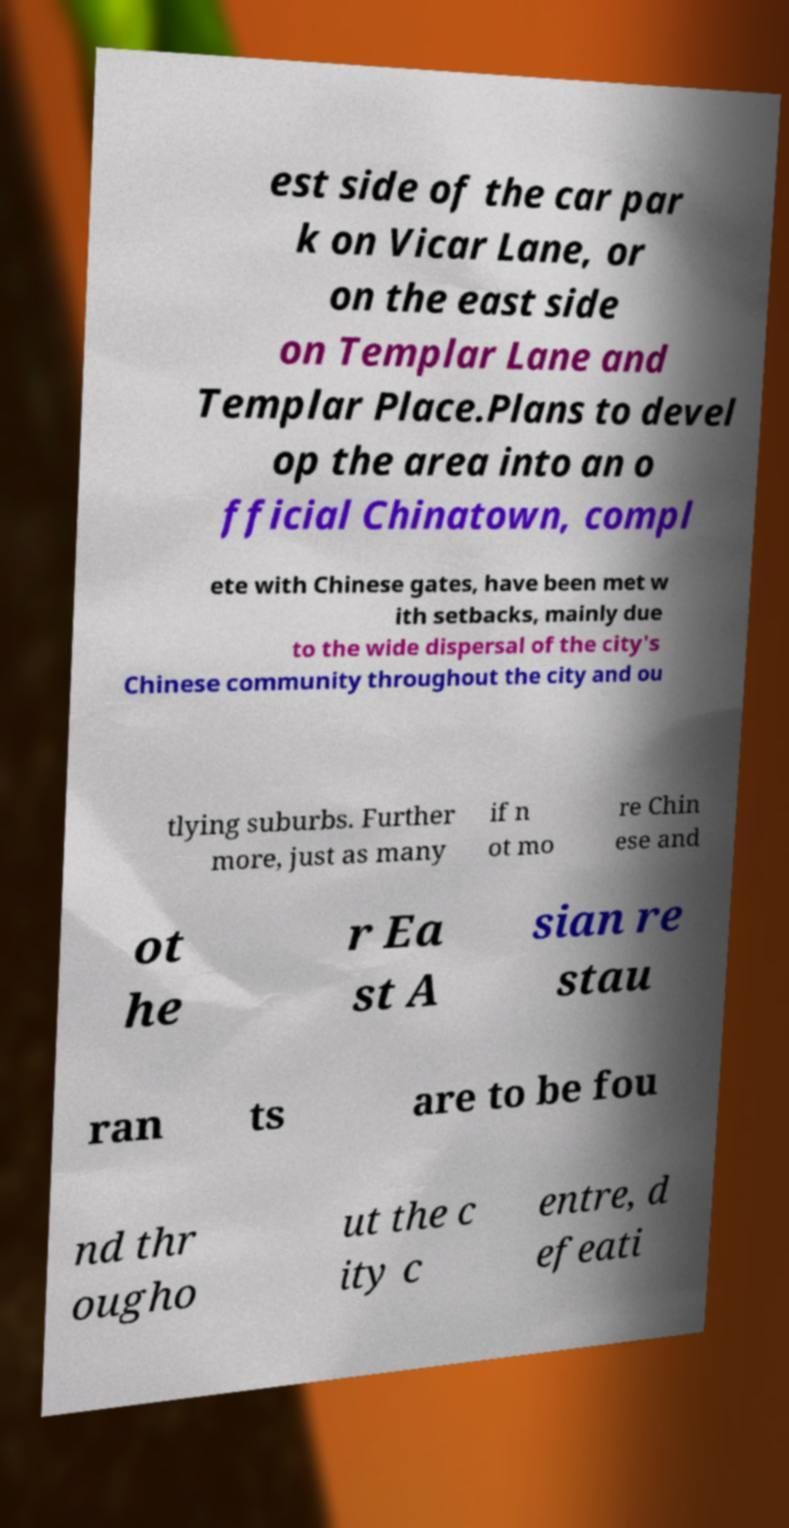Could you assist in decoding the text presented in this image and type it out clearly? est side of the car par k on Vicar Lane, or on the east side on Templar Lane and Templar Place.Plans to devel op the area into an o fficial Chinatown, compl ete with Chinese gates, have been met w ith setbacks, mainly due to the wide dispersal of the city's Chinese community throughout the city and ou tlying suburbs. Further more, just as many if n ot mo re Chin ese and ot he r Ea st A sian re stau ran ts are to be fou nd thr ougho ut the c ity c entre, d efeati 